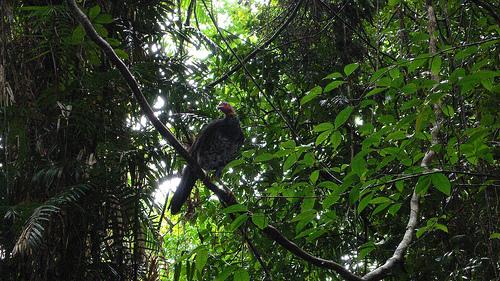Where is the bird?
Short answer required. On vine. Does that bird eat meat?
Answer briefly. Yes. Is the bird sitting on a tree?
Answer briefly. Yes. What animal is in the picture?
Quick response, please. Bird. Is this the jungle?
Keep it brief. Yes. What kind of bird is this?
Be succinct. Turkey. 